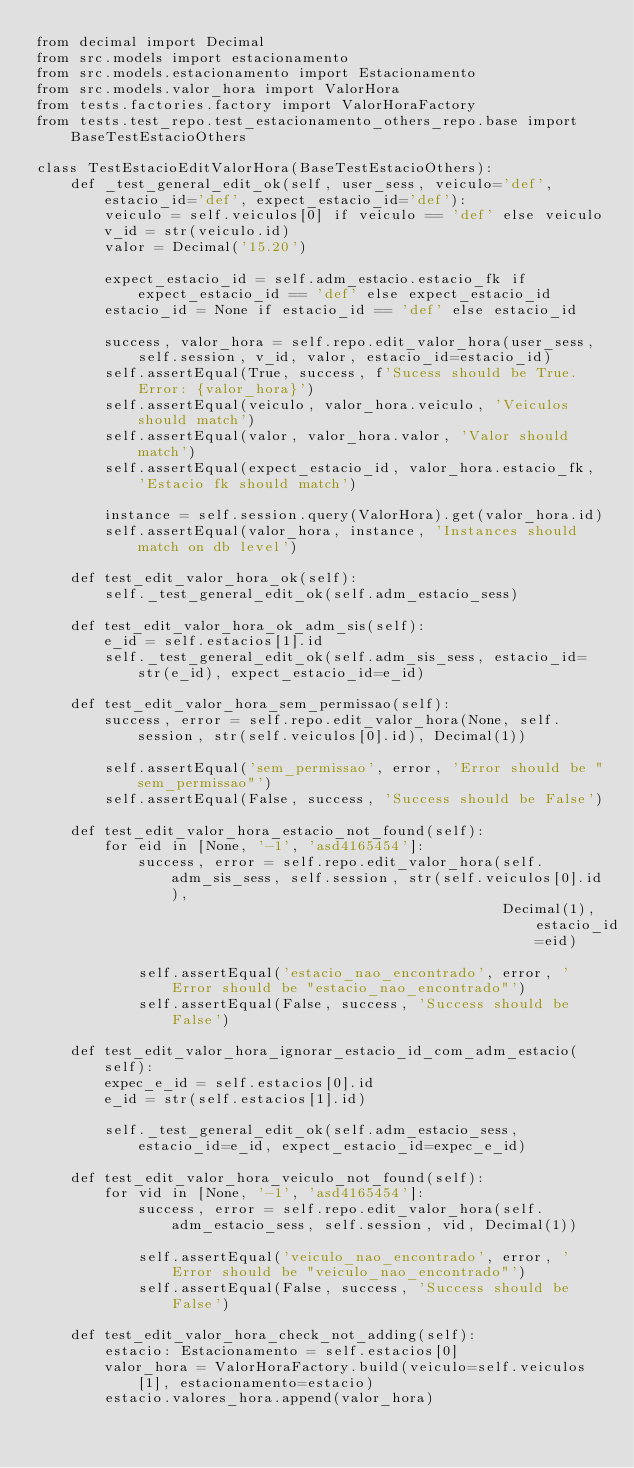<code> <loc_0><loc_0><loc_500><loc_500><_Python_>from decimal import Decimal
from src.models import estacionamento
from src.models.estacionamento import Estacionamento
from src.models.valor_hora import ValorHora
from tests.factories.factory import ValorHoraFactory
from tests.test_repo.test_estacionamento_others_repo.base import BaseTestEstacioOthers

class TestEstacioEditValorHora(BaseTestEstacioOthers):
    def _test_general_edit_ok(self, user_sess, veiculo='def', estacio_id='def', expect_estacio_id='def'):
        veiculo = self.veiculos[0] if veiculo == 'def' else veiculo
        v_id = str(veiculo.id)
        valor = Decimal('15.20')

        expect_estacio_id = self.adm_estacio.estacio_fk if expect_estacio_id == 'def' else expect_estacio_id
        estacio_id = None if estacio_id == 'def' else estacio_id

        success, valor_hora = self.repo.edit_valor_hora(user_sess, self.session, v_id, valor, estacio_id=estacio_id)
        self.assertEqual(True, success, f'Sucess should be True. Error: {valor_hora}')
        self.assertEqual(veiculo, valor_hora.veiculo, 'Veiculos should match')
        self.assertEqual(valor, valor_hora.valor, 'Valor should match')
        self.assertEqual(expect_estacio_id, valor_hora.estacio_fk, 'Estacio fk should match')

        instance = self.session.query(ValorHora).get(valor_hora.id)
        self.assertEqual(valor_hora, instance, 'Instances should match on db level')

    def test_edit_valor_hora_ok(self):
        self._test_general_edit_ok(self.adm_estacio_sess)

    def test_edit_valor_hora_ok_adm_sis(self):
        e_id = self.estacios[1].id
        self._test_general_edit_ok(self.adm_sis_sess, estacio_id=str(e_id), expect_estacio_id=e_id)

    def test_edit_valor_hora_sem_permissao(self):
        success, error = self.repo.edit_valor_hora(None, self.session, str(self.veiculos[0].id), Decimal(1))

        self.assertEqual('sem_permissao', error, 'Error should be "sem_permissao"')
        self.assertEqual(False, success, 'Success should be False')

    def test_edit_valor_hora_estacio_not_found(self):
        for eid in [None, '-1', 'asd4165454']:
            success, error = self.repo.edit_valor_hora(self.adm_sis_sess, self.session, str(self.veiculos[0].id),
                                                       Decimal(1), estacio_id=eid)

            self.assertEqual('estacio_nao_encontrado', error, 'Error should be "estacio_nao_encontrado"')
            self.assertEqual(False, success, 'Success should be False')

    def test_edit_valor_hora_ignorar_estacio_id_com_adm_estacio(self):
        expec_e_id = self.estacios[0].id
        e_id = str(self.estacios[1].id)

        self._test_general_edit_ok(self.adm_estacio_sess, estacio_id=e_id, expect_estacio_id=expec_e_id)

    def test_edit_valor_hora_veiculo_not_found(self):
        for vid in [None, '-1', 'asd4165454']:
            success, error = self.repo.edit_valor_hora(self.adm_estacio_sess, self.session, vid, Decimal(1))

            self.assertEqual('veiculo_nao_encontrado', error, 'Error should be "veiculo_nao_encontrado"')
            self.assertEqual(False, success, 'Success should be False')

    def test_edit_valor_hora_check_not_adding(self):
        estacio: Estacionamento = self.estacios[0]
        valor_hora = ValorHoraFactory.build(veiculo=self.veiculos[1], estacionamento=estacio)
        estacio.valores_hora.append(valor_hora)
</code> 